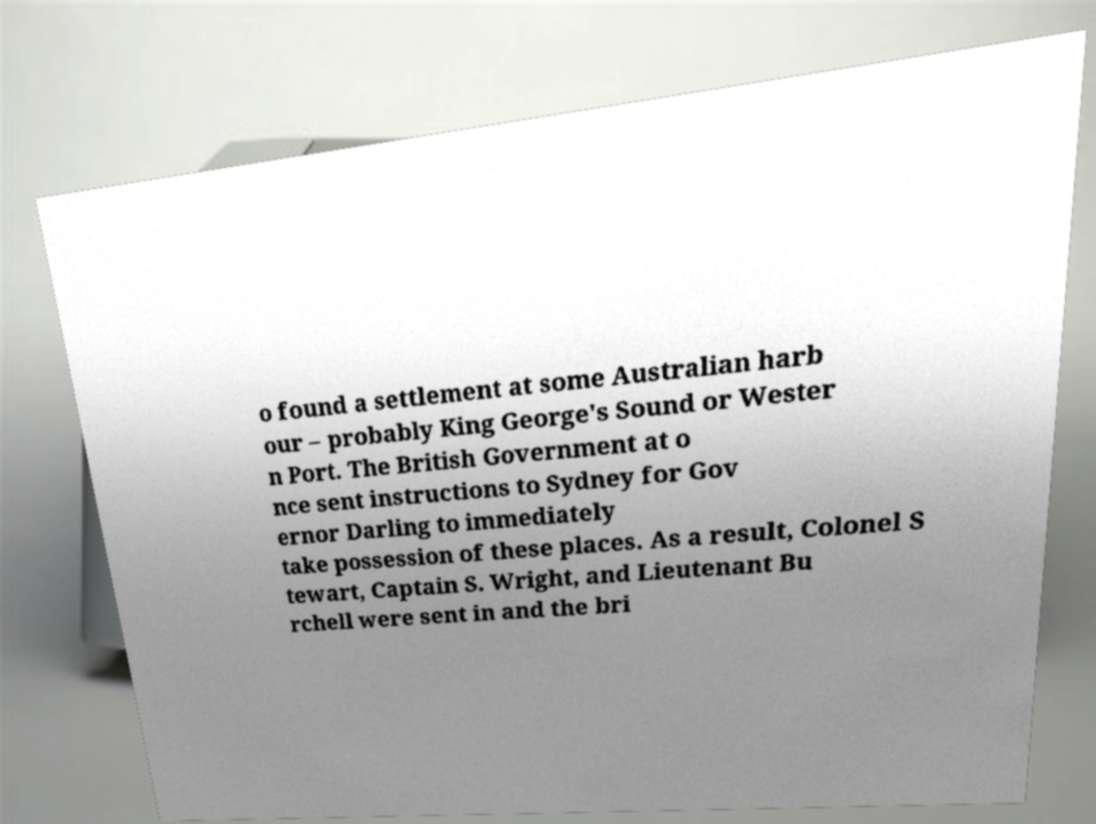Please identify and transcribe the text found in this image. o found a settlement at some Australian harb our – probably King George's Sound or Wester n Port. The British Government at o nce sent instructions to Sydney for Gov ernor Darling to immediately take possession of these places. As a result, Colonel S tewart, Captain S. Wright, and Lieutenant Bu rchell were sent in and the bri 